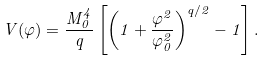<formula> <loc_0><loc_0><loc_500><loc_500>V ( \varphi ) = \frac { M _ { 0 } ^ { 4 } } { q } \left [ \left ( 1 + \frac { \varphi ^ { 2 } } { \varphi _ { 0 } ^ { 2 } } \right ) ^ { q / 2 } - 1 \right ] .</formula> 